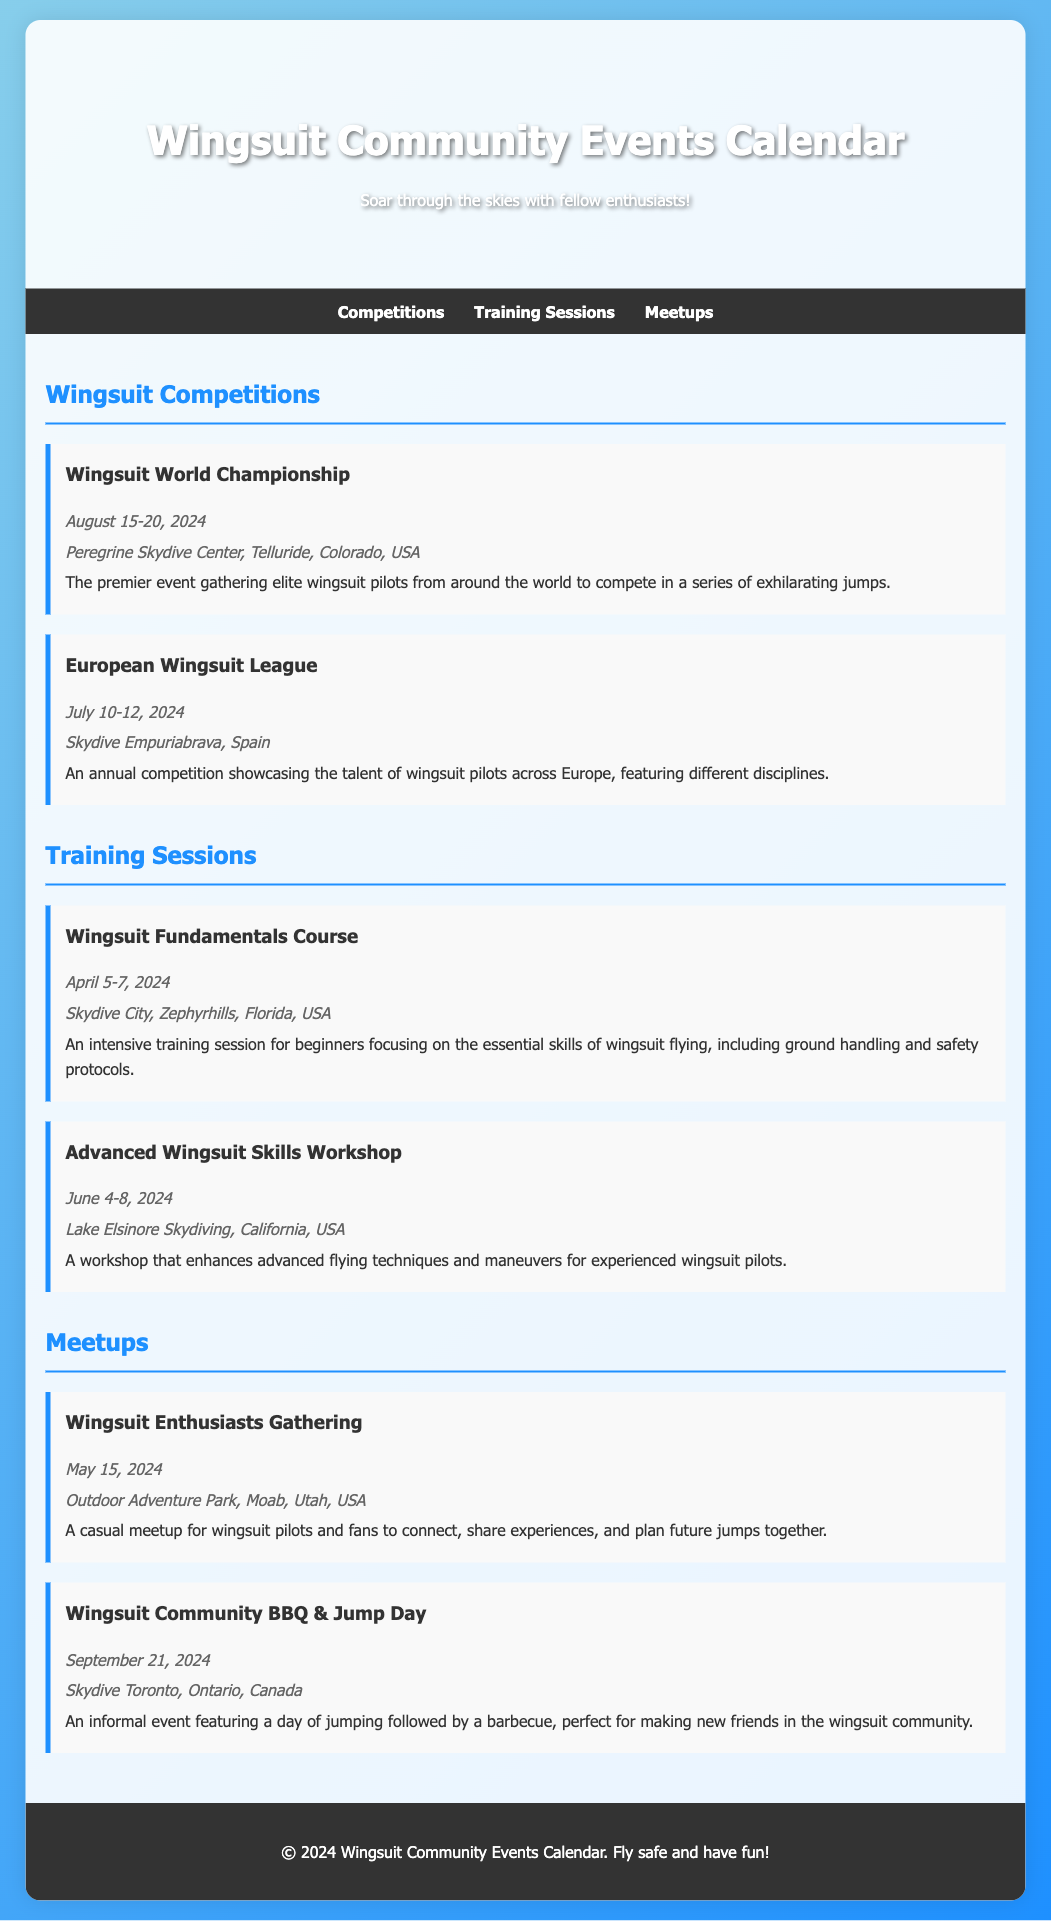What is the date of the Wingsuit World Championship? The event date is explicitly listed in the document under the Wingsuit Competitions section.
Answer: August 15-20, 2024 Where is the European Wingsuit League held? The location for this competition is provided in the event description of the document.
Answer: Skydive Empuriabrava, Spain What type of event is the Wingsuit Community BBQ & Jump Day? This event is categorized under meetups and described in the document as a casual gathering that includes both jumping and a barbecue.
Answer: Informal event What is the main focus of the Wingsuit Fundamentals Course? The document outlines the main objective of this training session, highlighting its content for beginners.
Answer: Essential skills of wingsuit flying How many days does the Advanced Wingsuit Skills Workshop last? The duration of this workshop is indicated in the event details given in the document.
Answer: 5 days When is the Wingsuit Enthusiasts Gathering taking place? The specific date is mentioned in the description of the meetup event in the document.
Answer: May 15, 2024 What location is specified for the Wingsuit World Championship? The document clearly states the venue for this competition within the event description.
Answer: Peregrine Skydive Center, Telluride, Colorado, USA What kind of experiences can attendees share at the Wingsuit Enthusiasts Gathering? The document explains the purpose of this gathering, highlighting its focus on connection and experience-sharing.
Answer: Experiences What is the primary activity planned for the Wingsuit Community BBQ & Jump Day? The document specifies the main activities associated with this meetup.
Answer: Jumping followed by a barbecue 